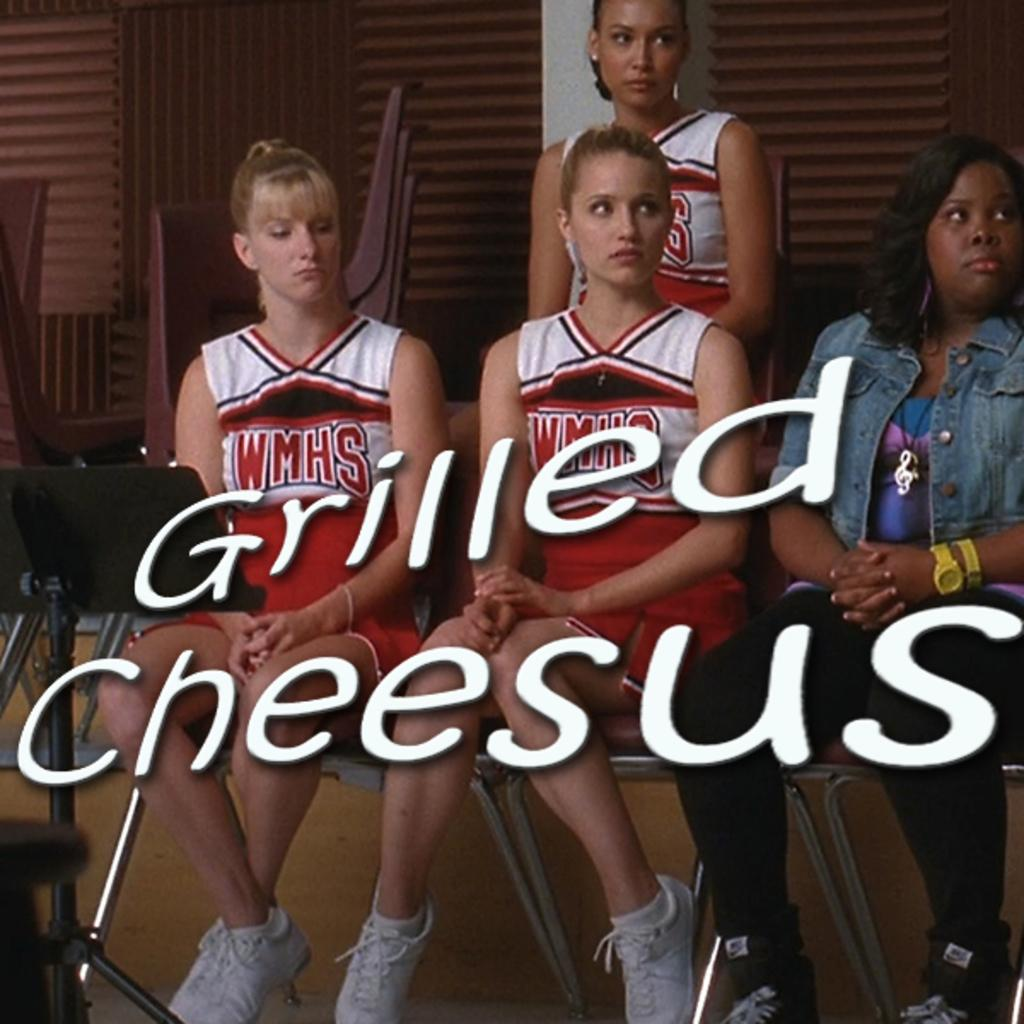<image>
Share a concise interpretation of the image provided. A group of cheerleaders with the words Grilled Cheesus superimposed in front of them. 